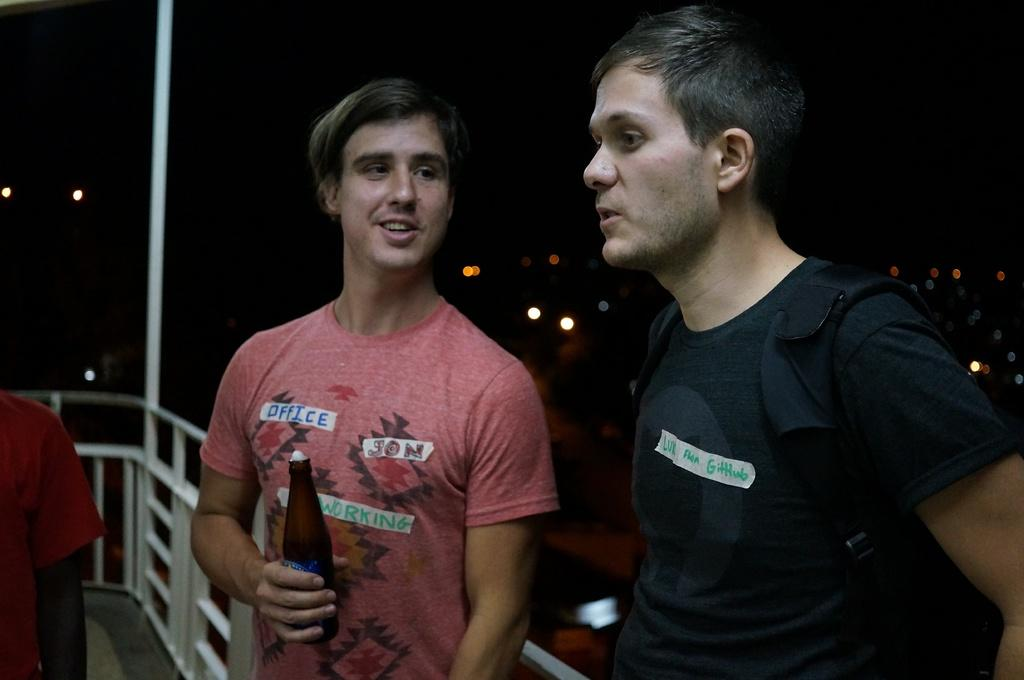How many people are in the image? There are two men in the image. What are the men doing in the image? The men are standing and talking to each other. Can you describe any objects the men are holding or wearing? One man is holding a beer bottle, and the other man is wearing a backpack. Where are the men standing in the image? The men are standing beside a railing. What historical discovery are the men discussing in the image? There is no indication in the image that the men are discussing any historical discovery. 